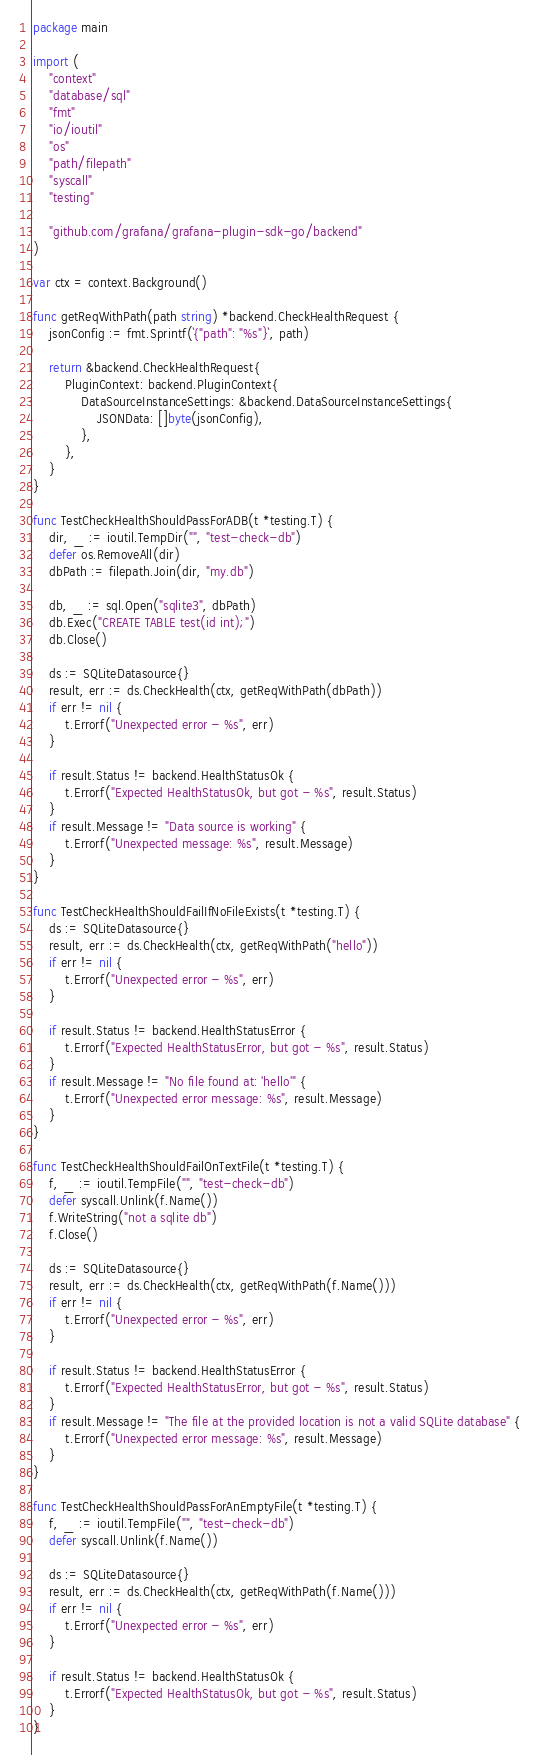<code> <loc_0><loc_0><loc_500><loc_500><_Go_>package main

import (
	"context"
	"database/sql"
	"fmt"
	"io/ioutil"
	"os"
	"path/filepath"
	"syscall"
	"testing"

	"github.com/grafana/grafana-plugin-sdk-go/backend"
)

var ctx = context.Background()

func getReqWithPath(path string) *backend.CheckHealthRequest {
	jsonConfig := fmt.Sprintf(`{"path": "%s"}`, path)

	return &backend.CheckHealthRequest{
		PluginContext: backend.PluginContext{
			DataSourceInstanceSettings: &backend.DataSourceInstanceSettings{
				JSONData: []byte(jsonConfig),
			},
		},
	}
}

func TestCheckHealthShouldPassForADB(t *testing.T) {
	dir, _ := ioutil.TempDir("", "test-check-db")
	defer os.RemoveAll(dir)
	dbPath := filepath.Join(dir, "my.db")

	db, _ := sql.Open("sqlite3", dbPath)
	db.Exec("CREATE TABLE test(id int);")
	db.Close()

	ds := SQLiteDatasource{}
	result, err := ds.CheckHealth(ctx, getReqWithPath(dbPath))
	if err != nil {
		t.Errorf("Unexpected error - %s", err)
	}

	if result.Status != backend.HealthStatusOk {
		t.Errorf("Expected HealthStatusOk, but got - %s", result.Status)
	}
	if result.Message != "Data source is working" {
		t.Errorf("Unexpected message: %s", result.Message)
	}
}

func TestCheckHealthShouldFailIfNoFileExists(t *testing.T) {
	ds := SQLiteDatasource{}
	result, err := ds.CheckHealth(ctx, getReqWithPath("hello"))
	if err != nil {
		t.Errorf("Unexpected error - %s", err)
	}

	if result.Status != backend.HealthStatusError {
		t.Errorf("Expected HealthStatusError, but got - %s", result.Status)
	}
	if result.Message != "No file found at: 'hello'" {
		t.Errorf("Unexpected error message: %s", result.Message)
	}
}

func TestCheckHealthShouldFailOnTextFile(t *testing.T) {
	f, _ := ioutil.TempFile("", "test-check-db")
	defer syscall.Unlink(f.Name())
	f.WriteString("not a sqlite db")
	f.Close()

	ds := SQLiteDatasource{}
	result, err := ds.CheckHealth(ctx, getReqWithPath(f.Name()))
	if err != nil {
		t.Errorf("Unexpected error - %s", err)
	}

	if result.Status != backend.HealthStatusError {
		t.Errorf("Expected HealthStatusError, but got - %s", result.Status)
	}
	if result.Message != "The file at the provided location is not a valid SQLite database" {
		t.Errorf("Unexpected error message: %s", result.Message)
	}
}

func TestCheckHealthShouldPassForAnEmptyFile(t *testing.T) {
	f, _ := ioutil.TempFile("", "test-check-db")
	defer syscall.Unlink(f.Name())

	ds := SQLiteDatasource{}
	result, err := ds.CheckHealth(ctx, getReqWithPath(f.Name()))
	if err != nil {
		t.Errorf("Unexpected error - %s", err)
	}

	if result.Status != backend.HealthStatusOk {
		t.Errorf("Expected HealthStatusOk, but got - %s", result.Status)
	}
}
</code> 